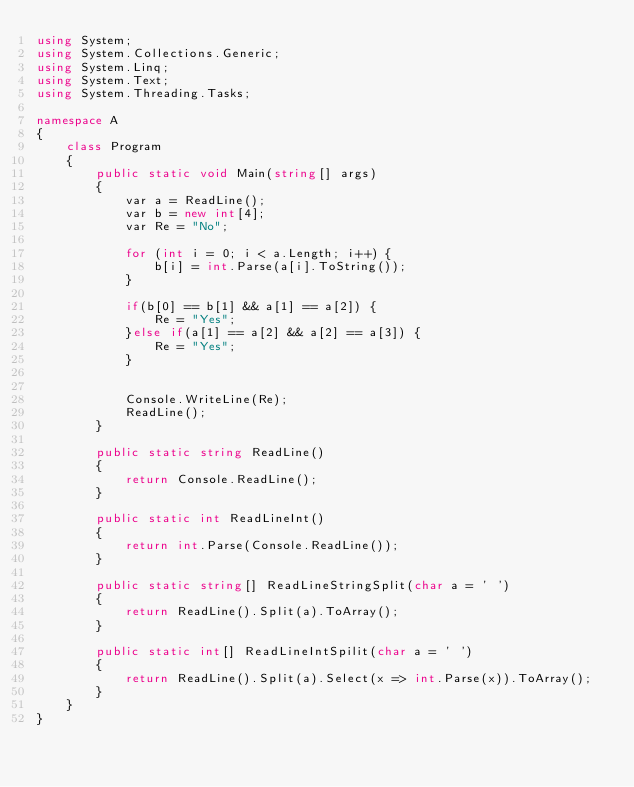Convert code to text. <code><loc_0><loc_0><loc_500><loc_500><_C#_>using System;
using System.Collections.Generic;
using System.Linq;
using System.Text;
using System.Threading.Tasks;

namespace A
{
    class Program
    {
        public static void Main(string[] args)
        {
            var a = ReadLine();
            var b = new int[4];
            var Re = "No";

            for (int i = 0; i < a.Length; i++) {
                b[i] = int.Parse(a[i].ToString());
            }

            if(b[0] == b[1] && a[1] == a[2]) {
                Re = "Yes";
            }else if(a[1] == a[2] && a[2] == a[3]) {
                Re = "Yes";
            }


            Console.WriteLine(Re);
            ReadLine();
        }

        public static string ReadLine()
        {
            return Console.ReadLine();
        }

        public static int ReadLineInt()
        {
            return int.Parse(Console.ReadLine());
        }

        public static string[] ReadLineStringSplit(char a = ' ')
        {
            return ReadLine().Split(a).ToArray();
        }

        public static int[] ReadLineIntSpilit(char a = ' ')
        {
            return ReadLine().Split(a).Select(x => int.Parse(x)).ToArray();
        }
    }
}</code> 